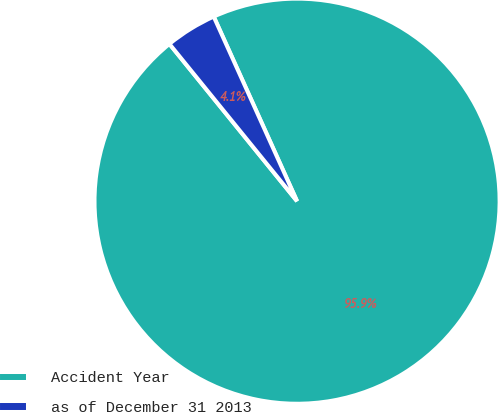Convert chart. <chart><loc_0><loc_0><loc_500><loc_500><pie_chart><fcel>Accident Year<fcel>as of December 31 2013<nl><fcel>95.9%<fcel>4.1%<nl></chart> 